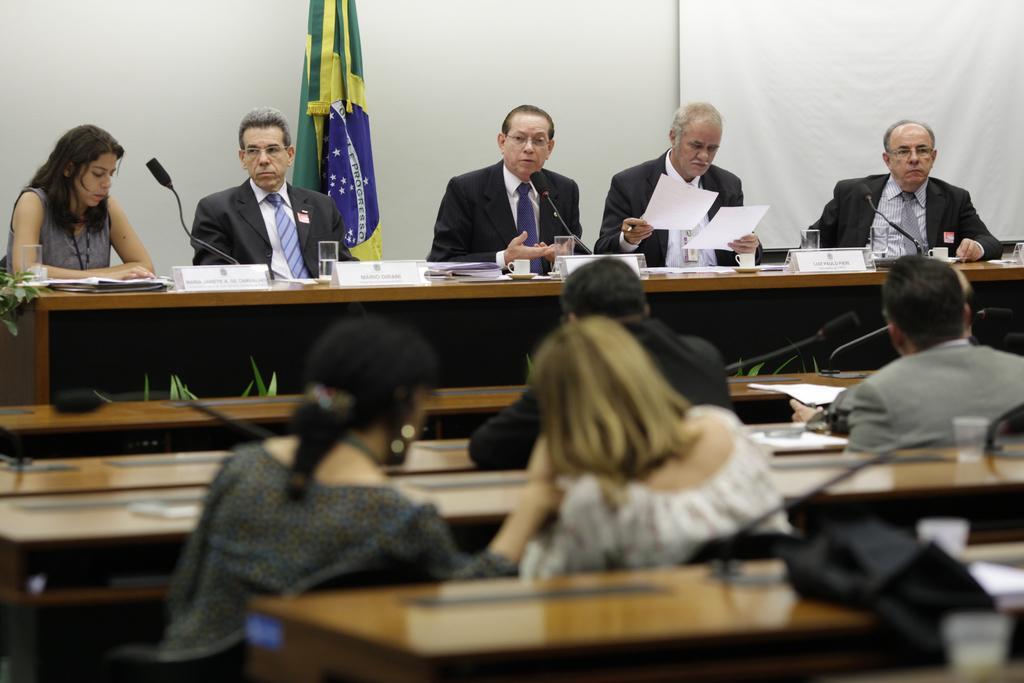In one or two sentences, can you explain what this image depicts? In this picture group of people sitting on the chair. We can see tables. On the table we can see microphones,papers,board,glass. On the background we can see wall and flag. 